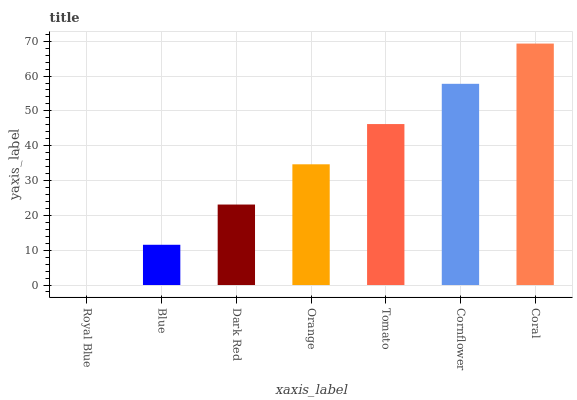Is Royal Blue the minimum?
Answer yes or no. Yes. Is Coral the maximum?
Answer yes or no. Yes. Is Blue the minimum?
Answer yes or no. No. Is Blue the maximum?
Answer yes or no. No. Is Blue greater than Royal Blue?
Answer yes or no. Yes. Is Royal Blue less than Blue?
Answer yes or no. Yes. Is Royal Blue greater than Blue?
Answer yes or no. No. Is Blue less than Royal Blue?
Answer yes or no. No. Is Orange the high median?
Answer yes or no. Yes. Is Orange the low median?
Answer yes or no. Yes. Is Tomato the high median?
Answer yes or no. No. Is Royal Blue the low median?
Answer yes or no. No. 